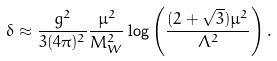Convert formula to latex. <formula><loc_0><loc_0><loc_500><loc_500>\delta \approx \frac { g ^ { 2 } } { 3 ( 4 \pi ) ^ { 2 } } \frac { \mu ^ { 2 } } { M _ { W } ^ { 2 } } \log \left ( \frac { ( 2 + \sqrt { 3 } ) \mu ^ { 2 } } { \Lambda ^ { 2 } } \right ) .</formula> 